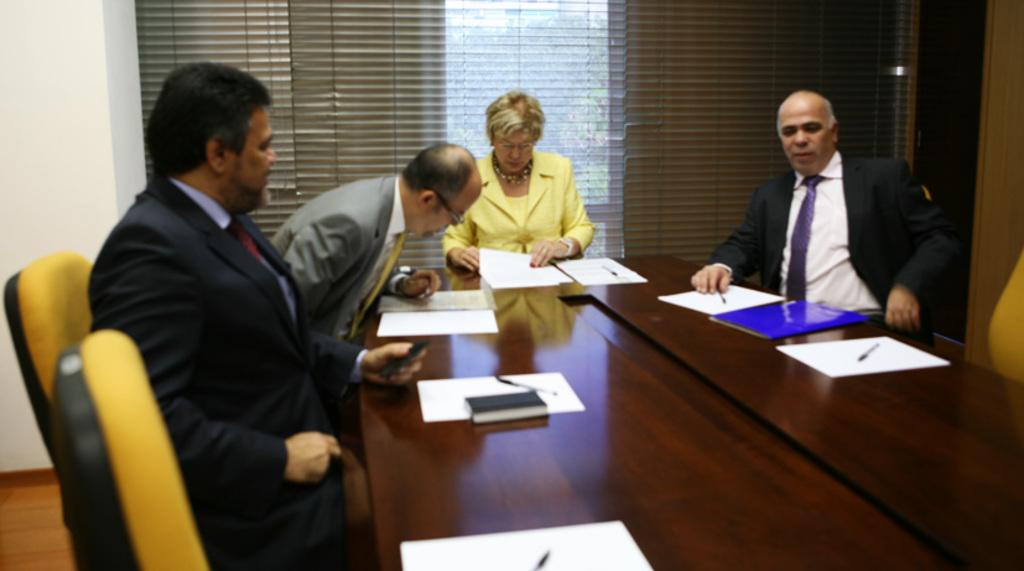What are the persons in the image doing? The persons in the image are sitting on chairs. What is in front of the persons? There is a table in front of the persons. What items can be seen on the table? There is a book, papers, and a pen on the table. Is there any source of natural light in the image? Yes, there is a window behind one of the persons. How many legs does the book have in the image? The book does not have legs; it is a flat object resting on the table. How many minutes does it take for the pen to write on the paper in the image? The image does not show the pen in motion or provide any information about the passage of time, so it is impossible to determine how many minutes it takes for the pen to write on the paper. 